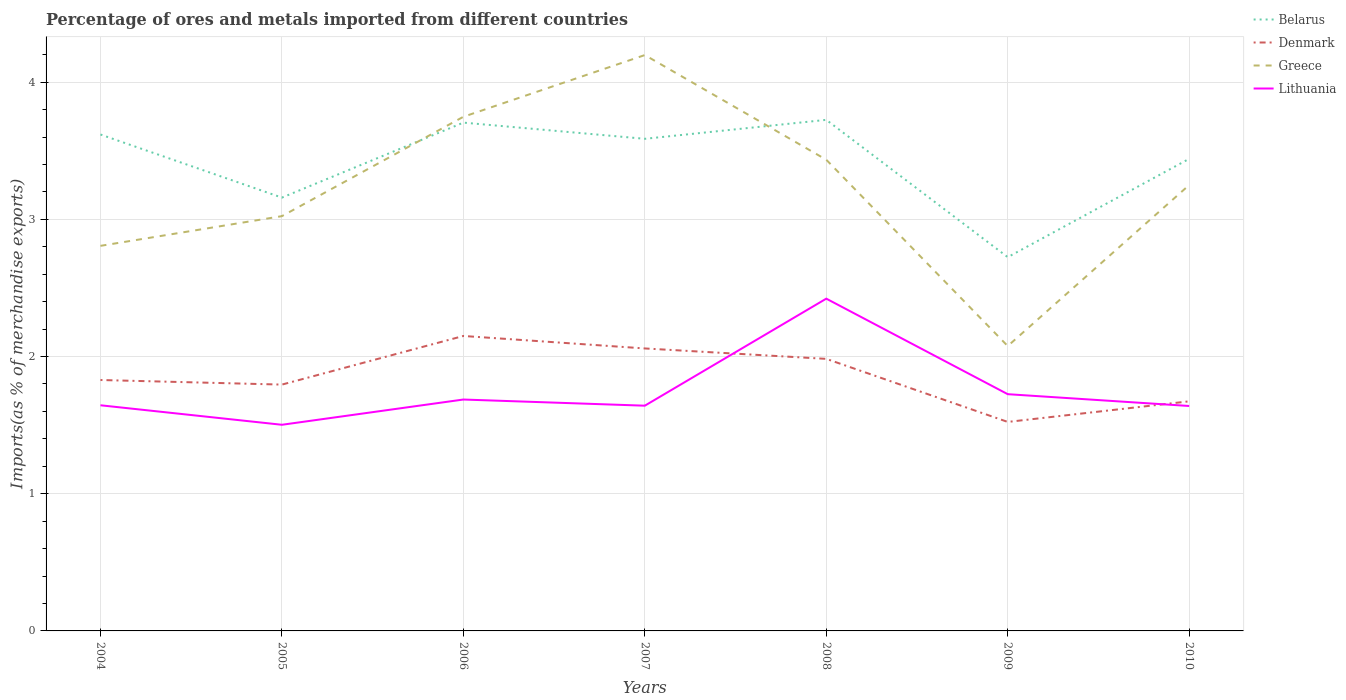How many different coloured lines are there?
Make the answer very short. 4. Does the line corresponding to Belarus intersect with the line corresponding to Greece?
Ensure brevity in your answer.  Yes. Is the number of lines equal to the number of legend labels?
Give a very brief answer. Yes. Across all years, what is the maximum percentage of imports to different countries in Greece?
Offer a very short reply. 2.08. What is the total percentage of imports to different countries in Lithuania in the graph?
Your answer should be compact. 0.01. What is the difference between the highest and the second highest percentage of imports to different countries in Denmark?
Ensure brevity in your answer.  0.63. Is the percentage of imports to different countries in Belarus strictly greater than the percentage of imports to different countries in Denmark over the years?
Ensure brevity in your answer.  No. How many lines are there?
Ensure brevity in your answer.  4. How many years are there in the graph?
Your answer should be very brief. 7. What is the difference between two consecutive major ticks on the Y-axis?
Offer a terse response. 1. Are the values on the major ticks of Y-axis written in scientific E-notation?
Your response must be concise. No. How many legend labels are there?
Your response must be concise. 4. How are the legend labels stacked?
Your answer should be very brief. Vertical. What is the title of the graph?
Offer a very short reply. Percentage of ores and metals imported from different countries. Does "East Asia (developing only)" appear as one of the legend labels in the graph?
Your response must be concise. No. What is the label or title of the X-axis?
Make the answer very short. Years. What is the label or title of the Y-axis?
Your response must be concise. Imports(as % of merchandise exports). What is the Imports(as % of merchandise exports) of Belarus in 2004?
Make the answer very short. 3.62. What is the Imports(as % of merchandise exports) of Denmark in 2004?
Make the answer very short. 1.83. What is the Imports(as % of merchandise exports) of Greece in 2004?
Make the answer very short. 2.81. What is the Imports(as % of merchandise exports) of Lithuania in 2004?
Your answer should be very brief. 1.64. What is the Imports(as % of merchandise exports) of Belarus in 2005?
Keep it short and to the point. 3.16. What is the Imports(as % of merchandise exports) of Denmark in 2005?
Give a very brief answer. 1.8. What is the Imports(as % of merchandise exports) in Greece in 2005?
Offer a very short reply. 3.02. What is the Imports(as % of merchandise exports) of Lithuania in 2005?
Offer a terse response. 1.5. What is the Imports(as % of merchandise exports) in Belarus in 2006?
Your response must be concise. 3.71. What is the Imports(as % of merchandise exports) in Denmark in 2006?
Offer a terse response. 2.15. What is the Imports(as % of merchandise exports) of Greece in 2006?
Provide a succinct answer. 3.75. What is the Imports(as % of merchandise exports) of Lithuania in 2006?
Your response must be concise. 1.69. What is the Imports(as % of merchandise exports) in Belarus in 2007?
Keep it short and to the point. 3.59. What is the Imports(as % of merchandise exports) of Denmark in 2007?
Your answer should be very brief. 2.06. What is the Imports(as % of merchandise exports) in Greece in 2007?
Provide a short and direct response. 4.2. What is the Imports(as % of merchandise exports) of Lithuania in 2007?
Provide a short and direct response. 1.64. What is the Imports(as % of merchandise exports) in Belarus in 2008?
Ensure brevity in your answer.  3.73. What is the Imports(as % of merchandise exports) in Denmark in 2008?
Make the answer very short. 1.98. What is the Imports(as % of merchandise exports) in Greece in 2008?
Ensure brevity in your answer.  3.43. What is the Imports(as % of merchandise exports) of Lithuania in 2008?
Ensure brevity in your answer.  2.42. What is the Imports(as % of merchandise exports) in Belarus in 2009?
Provide a succinct answer. 2.72. What is the Imports(as % of merchandise exports) of Denmark in 2009?
Ensure brevity in your answer.  1.52. What is the Imports(as % of merchandise exports) of Greece in 2009?
Ensure brevity in your answer.  2.08. What is the Imports(as % of merchandise exports) in Lithuania in 2009?
Your answer should be very brief. 1.73. What is the Imports(as % of merchandise exports) of Belarus in 2010?
Offer a very short reply. 3.44. What is the Imports(as % of merchandise exports) of Denmark in 2010?
Your answer should be very brief. 1.67. What is the Imports(as % of merchandise exports) in Greece in 2010?
Your answer should be compact. 3.25. What is the Imports(as % of merchandise exports) of Lithuania in 2010?
Make the answer very short. 1.64. Across all years, what is the maximum Imports(as % of merchandise exports) of Belarus?
Make the answer very short. 3.73. Across all years, what is the maximum Imports(as % of merchandise exports) of Denmark?
Offer a very short reply. 2.15. Across all years, what is the maximum Imports(as % of merchandise exports) of Greece?
Make the answer very short. 4.2. Across all years, what is the maximum Imports(as % of merchandise exports) of Lithuania?
Offer a very short reply. 2.42. Across all years, what is the minimum Imports(as % of merchandise exports) in Belarus?
Keep it short and to the point. 2.72. Across all years, what is the minimum Imports(as % of merchandise exports) of Denmark?
Your response must be concise. 1.52. Across all years, what is the minimum Imports(as % of merchandise exports) of Greece?
Your answer should be compact. 2.08. Across all years, what is the minimum Imports(as % of merchandise exports) of Lithuania?
Offer a very short reply. 1.5. What is the total Imports(as % of merchandise exports) in Belarus in the graph?
Provide a succinct answer. 23.96. What is the total Imports(as % of merchandise exports) of Denmark in the graph?
Provide a short and direct response. 13.01. What is the total Imports(as % of merchandise exports) of Greece in the graph?
Your response must be concise. 22.54. What is the total Imports(as % of merchandise exports) of Lithuania in the graph?
Your answer should be very brief. 12.26. What is the difference between the Imports(as % of merchandise exports) in Belarus in 2004 and that in 2005?
Make the answer very short. 0.46. What is the difference between the Imports(as % of merchandise exports) of Denmark in 2004 and that in 2005?
Provide a short and direct response. 0.03. What is the difference between the Imports(as % of merchandise exports) of Greece in 2004 and that in 2005?
Your response must be concise. -0.22. What is the difference between the Imports(as % of merchandise exports) of Lithuania in 2004 and that in 2005?
Give a very brief answer. 0.14. What is the difference between the Imports(as % of merchandise exports) of Belarus in 2004 and that in 2006?
Provide a succinct answer. -0.09. What is the difference between the Imports(as % of merchandise exports) in Denmark in 2004 and that in 2006?
Offer a very short reply. -0.32. What is the difference between the Imports(as % of merchandise exports) of Greece in 2004 and that in 2006?
Keep it short and to the point. -0.94. What is the difference between the Imports(as % of merchandise exports) in Lithuania in 2004 and that in 2006?
Provide a short and direct response. -0.04. What is the difference between the Imports(as % of merchandise exports) in Belarus in 2004 and that in 2007?
Your response must be concise. 0.03. What is the difference between the Imports(as % of merchandise exports) of Denmark in 2004 and that in 2007?
Your response must be concise. -0.23. What is the difference between the Imports(as % of merchandise exports) in Greece in 2004 and that in 2007?
Offer a terse response. -1.39. What is the difference between the Imports(as % of merchandise exports) in Lithuania in 2004 and that in 2007?
Provide a succinct answer. 0. What is the difference between the Imports(as % of merchandise exports) in Belarus in 2004 and that in 2008?
Offer a terse response. -0.11. What is the difference between the Imports(as % of merchandise exports) in Denmark in 2004 and that in 2008?
Your response must be concise. -0.15. What is the difference between the Imports(as % of merchandise exports) in Greece in 2004 and that in 2008?
Your answer should be very brief. -0.63. What is the difference between the Imports(as % of merchandise exports) of Lithuania in 2004 and that in 2008?
Keep it short and to the point. -0.78. What is the difference between the Imports(as % of merchandise exports) in Belarus in 2004 and that in 2009?
Give a very brief answer. 0.89. What is the difference between the Imports(as % of merchandise exports) of Denmark in 2004 and that in 2009?
Provide a short and direct response. 0.31. What is the difference between the Imports(as % of merchandise exports) in Greece in 2004 and that in 2009?
Ensure brevity in your answer.  0.73. What is the difference between the Imports(as % of merchandise exports) in Lithuania in 2004 and that in 2009?
Your response must be concise. -0.08. What is the difference between the Imports(as % of merchandise exports) in Belarus in 2004 and that in 2010?
Your answer should be compact. 0.18. What is the difference between the Imports(as % of merchandise exports) in Denmark in 2004 and that in 2010?
Provide a succinct answer. 0.16. What is the difference between the Imports(as % of merchandise exports) of Greece in 2004 and that in 2010?
Make the answer very short. -0.44. What is the difference between the Imports(as % of merchandise exports) in Lithuania in 2004 and that in 2010?
Offer a very short reply. 0.01. What is the difference between the Imports(as % of merchandise exports) of Belarus in 2005 and that in 2006?
Give a very brief answer. -0.55. What is the difference between the Imports(as % of merchandise exports) of Denmark in 2005 and that in 2006?
Provide a succinct answer. -0.35. What is the difference between the Imports(as % of merchandise exports) of Greece in 2005 and that in 2006?
Offer a very short reply. -0.72. What is the difference between the Imports(as % of merchandise exports) in Lithuania in 2005 and that in 2006?
Ensure brevity in your answer.  -0.18. What is the difference between the Imports(as % of merchandise exports) of Belarus in 2005 and that in 2007?
Your answer should be compact. -0.43. What is the difference between the Imports(as % of merchandise exports) in Denmark in 2005 and that in 2007?
Provide a short and direct response. -0.26. What is the difference between the Imports(as % of merchandise exports) of Greece in 2005 and that in 2007?
Your answer should be compact. -1.17. What is the difference between the Imports(as % of merchandise exports) of Lithuania in 2005 and that in 2007?
Your answer should be compact. -0.14. What is the difference between the Imports(as % of merchandise exports) in Belarus in 2005 and that in 2008?
Keep it short and to the point. -0.57. What is the difference between the Imports(as % of merchandise exports) of Denmark in 2005 and that in 2008?
Ensure brevity in your answer.  -0.19. What is the difference between the Imports(as % of merchandise exports) of Greece in 2005 and that in 2008?
Make the answer very short. -0.41. What is the difference between the Imports(as % of merchandise exports) of Lithuania in 2005 and that in 2008?
Offer a very short reply. -0.92. What is the difference between the Imports(as % of merchandise exports) of Belarus in 2005 and that in 2009?
Give a very brief answer. 0.43. What is the difference between the Imports(as % of merchandise exports) in Denmark in 2005 and that in 2009?
Provide a short and direct response. 0.27. What is the difference between the Imports(as % of merchandise exports) in Greece in 2005 and that in 2009?
Your response must be concise. 0.95. What is the difference between the Imports(as % of merchandise exports) of Lithuania in 2005 and that in 2009?
Ensure brevity in your answer.  -0.22. What is the difference between the Imports(as % of merchandise exports) of Belarus in 2005 and that in 2010?
Ensure brevity in your answer.  -0.28. What is the difference between the Imports(as % of merchandise exports) of Denmark in 2005 and that in 2010?
Your answer should be very brief. 0.12. What is the difference between the Imports(as % of merchandise exports) of Greece in 2005 and that in 2010?
Offer a very short reply. -0.23. What is the difference between the Imports(as % of merchandise exports) of Lithuania in 2005 and that in 2010?
Offer a very short reply. -0.14. What is the difference between the Imports(as % of merchandise exports) in Belarus in 2006 and that in 2007?
Keep it short and to the point. 0.12. What is the difference between the Imports(as % of merchandise exports) of Denmark in 2006 and that in 2007?
Your answer should be compact. 0.09. What is the difference between the Imports(as % of merchandise exports) in Greece in 2006 and that in 2007?
Provide a short and direct response. -0.45. What is the difference between the Imports(as % of merchandise exports) in Lithuania in 2006 and that in 2007?
Provide a succinct answer. 0.04. What is the difference between the Imports(as % of merchandise exports) of Belarus in 2006 and that in 2008?
Ensure brevity in your answer.  -0.02. What is the difference between the Imports(as % of merchandise exports) of Denmark in 2006 and that in 2008?
Your answer should be compact. 0.17. What is the difference between the Imports(as % of merchandise exports) in Greece in 2006 and that in 2008?
Offer a terse response. 0.31. What is the difference between the Imports(as % of merchandise exports) of Lithuania in 2006 and that in 2008?
Give a very brief answer. -0.74. What is the difference between the Imports(as % of merchandise exports) of Belarus in 2006 and that in 2009?
Offer a very short reply. 0.98. What is the difference between the Imports(as % of merchandise exports) of Denmark in 2006 and that in 2009?
Make the answer very short. 0.63. What is the difference between the Imports(as % of merchandise exports) in Greece in 2006 and that in 2009?
Provide a short and direct response. 1.67. What is the difference between the Imports(as % of merchandise exports) in Lithuania in 2006 and that in 2009?
Provide a short and direct response. -0.04. What is the difference between the Imports(as % of merchandise exports) in Belarus in 2006 and that in 2010?
Give a very brief answer. 0.26. What is the difference between the Imports(as % of merchandise exports) in Denmark in 2006 and that in 2010?
Provide a short and direct response. 0.48. What is the difference between the Imports(as % of merchandise exports) of Greece in 2006 and that in 2010?
Keep it short and to the point. 0.5. What is the difference between the Imports(as % of merchandise exports) in Lithuania in 2006 and that in 2010?
Ensure brevity in your answer.  0.05. What is the difference between the Imports(as % of merchandise exports) in Belarus in 2007 and that in 2008?
Your response must be concise. -0.14. What is the difference between the Imports(as % of merchandise exports) in Denmark in 2007 and that in 2008?
Make the answer very short. 0.08. What is the difference between the Imports(as % of merchandise exports) of Greece in 2007 and that in 2008?
Give a very brief answer. 0.76. What is the difference between the Imports(as % of merchandise exports) of Lithuania in 2007 and that in 2008?
Keep it short and to the point. -0.78. What is the difference between the Imports(as % of merchandise exports) in Belarus in 2007 and that in 2009?
Your answer should be very brief. 0.86. What is the difference between the Imports(as % of merchandise exports) in Denmark in 2007 and that in 2009?
Ensure brevity in your answer.  0.54. What is the difference between the Imports(as % of merchandise exports) of Greece in 2007 and that in 2009?
Your response must be concise. 2.12. What is the difference between the Imports(as % of merchandise exports) of Lithuania in 2007 and that in 2009?
Your answer should be compact. -0.08. What is the difference between the Imports(as % of merchandise exports) in Belarus in 2007 and that in 2010?
Your answer should be compact. 0.15. What is the difference between the Imports(as % of merchandise exports) of Denmark in 2007 and that in 2010?
Ensure brevity in your answer.  0.39. What is the difference between the Imports(as % of merchandise exports) of Greece in 2007 and that in 2010?
Offer a terse response. 0.95. What is the difference between the Imports(as % of merchandise exports) of Lithuania in 2007 and that in 2010?
Ensure brevity in your answer.  0. What is the difference between the Imports(as % of merchandise exports) of Denmark in 2008 and that in 2009?
Offer a terse response. 0.46. What is the difference between the Imports(as % of merchandise exports) in Greece in 2008 and that in 2009?
Your answer should be compact. 1.36. What is the difference between the Imports(as % of merchandise exports) in Lithuania in 2008 and that in 2009?
Provide a succinct answer. 0.7. What is the difference between the Imports(as % of merchandise exports) of Belarus in 2008 and that in 2010?
Your answer should be very brief. 0.28. What is the difference between the Imports(as % of merchandise exports) in Denmark in 2008 and that in 2010?
Make the answer very short. 0.31. What is the difference between the Imports(as % of merchandise exports) of Greece in 2008 and that in 2010?
Make the answer very short. 0.18. What is the difference between the Imports(as % of merchandise exports) in Lithuania in 2008 and that in 2010?
Ensure brevity in your answer.  0.78. What is the difference between the Imports(as % of merchandise exports) in Belarus in 2009 and that in 2010?
Offer a terse response. -0.72. What is the difference between the Imports(as % of merchandise exports) of Denmark in 2009 and that in 2010?
Your answer should be very brief. -0.15. What is the difference between the Imports(as % of merchandise exports) of Greece in 2009 and that in 2010?
Offer a very short reply. -1.17. What is the difference between the Imports(as % of merchandise exports) in Lithuania in 2009 and that in 2010?
Offer a terse response. 0.09. What is the difference between the Imports(as % of merchandise exports) of Belarus in 2004 and the Imports(as % of merchandise exports) of Denmark in 2005?
Keep it short and to the point. 1.82. What is the difference between the Imports(as % of merchandise exports) in Belarus in 2004 and the Imports(as % of merchandise exports) in Greece in 2005?
Provide a succinct answer. 0.59. What is the difference between the Imports(as % of merchandise exports) in Belarus in 2004 and the Imports(as % of merchandise exports) in Lithuania in 2005?
Offer a very short reply. 2.12. What is the difference between the Imports(as % of merchandise exports) of Denmark in 2004 and the Imports(as % of merchandise exports) of Greece in 2005?
Your answer should be very brief. -1.19. What is the difference between the Imports(as % of merchandise exports) in Denmark in 2004 and the Imports(as % of merchandise exports) in Lithuania in 2005?
Offer a very short reply. 0.33. What is the difference between the Imports(as % of merchandise exports) of Greece in 2004 and the Imports(as % of merchandise exports) of Lithuania in 2005?
Keep it short and to the point. 1.3. What is the difference between the Imports(as % of merchandise exports) of Belarus in 2004 and the Imports(as % of merchandise exports) of Denmark in 2006?
Offer a terse response. 1.47. What is the difference between the Imports(as % of merchandise exports) of Belarus in 2004 and the Imports(as % of merchandise exports) of Greece in 2006?
Provide a succinct answer. -0.13. What is the difference between the Imports(as % of merchandise exports) of Belarus in 2004 and the Imports(as % of merchandise exports) of Lithuania in 2006?
Your answer should be very brief. 1.93. What is the difference between the Imports(as % of merchandise exports) of Denmark in 2004 and the Imports(as % of merchandise exports) of Greece in 2006?
Provide a succinct answer. -1.92. What is the difference between the Imports(as % of merchandise exports) of Denmark in 2004 and the Imports(as % of merchandise exports) of Lithuania in 2006?
Offer a terse response. 0.14. What is the difference between the Imports(as % of merchandise exports) in Greece in 2004 and the Imports(as % of merchandise exports) in Lithuania in 2006?
Your answer should be compact. 1.12. What is the difference between the Imports(as % of merchandise exports) of Belarus in 2004 and the Imports(as % of merchandise exports) of Denmark in 2007?
Ensure brevity in your answer.  1.56. What is the difference between the Imports(as % of merchandise exports) in Belarus in 2004 and the Imports(as % of merchandise exports) in Greece in 2007?
Keep it short and to the point. -0.58. What is the difference between the Imports(as % of merchandise exports) in Belarus in 2004 and the Imports(as % of merchandise exports) in Lithuania in 2007?
Make the answer very short. 1.98. What is the difference between the Imports(as % of merchandise exports) of Denmark in 2004 and the Imports(as % of merchandise exports) of Greece in 2007?
Offer a very short reply. -2.37. What is the difference between the Imports(as % of merchandise exports) in Denmark in 2004 and the Imports(as % of merchandise exports) in Lithuania in 2007?
Your response must be concise. 0.19. What is the difference between the Imports(as % of merchandise exports) in Greece in 2004 and the Imports(as % of merchandise exports) in Lithuania in 2007?
Your answer should be compact. 1.17. What is the difference between the Imports(as % of merchandise exports) in Belarus in 2004 and the Imports(as % of merchandise exports) in Denmark in 2008?
Provide a short and direct response. 1.64. What is the difference between the Imports(as % of merchandise exports) in Belarus in 2004 and the Imports(as % of merchandise exports) in Greece in 2008?
Provide a succinct answer. 0.18. What is the difference between the Imports(as % of merchandise exports) in Belarus in 2004 and the Imports(as % of merchandise exports) in Lithuania in 2008?
Your response must be concise. 1.2. What is the difference between the Imports(as % of merchandise exports) in Denmark in 2004 and the Imports(as % of merchandise exports) in Greece in 2008?
Provide a short and direct response. -1.61. What is the difference between the Imports(as % of merchandise exports) of Denmark in 2004 and the Imports(as % of merchandise exports) of Lithuania in 2008?
Your answer should be compact. -0.59. What is the difference between the Imports(as % of merchandise exports) in Greece in 2004 and the Imports(as % of merchandise exports) in Lithuania in 2008?
Your answer should be compact. 0.38. What is the difference between the Imports(as % of merchandise exports) in Belarus in 2004 and the Imports(as % of merchandise exports) in Denmark in 2009?
Make the answer very short. 2.1. What is the difference between the Imports(as % of merchandise exports) of Belarus in 2004 and the Imports(as % of merchandise exports) of Greece in 2009?
Your answer should be very brief. 1.54. What is the difference between the Imports(as % of merchandise exports) of Belarus in 2004 and the Imports(as % of merchandise exports) of Lithuania in 2009?
Offer a very short reply. 1.89. What is the difference between the Imports(as % of merchandise exports) of Denmark in 2004 and the Imports(as % of merchandise exports) of Greece in 2009?
Provide a succinct answer. -0.25. What is the difference between the Imports(as % of merchandise exports) of Denmark in 2004 and the Imports(as % of merchandise exports) of Lithuania in 2009?
Provide a short and direct response. 0.1. What is the difference between the Imports(as % of merchandise exports) in Greece in 2004 and the Imports(as % of merchandise exports) in Lithuania in 2009?
Give a very brief answer. 1.08. What is the difference between the Imports(as % of merchandise exports) in Belarus in 2004 and the Imports(as % of merchandise exports) in Denmark in 2010?
Your response must be concise. 1.94. What is the difference between the Imports(as % of merchandise exports) of Belarus in 2004 and the Imports(as % of merchandise exports) of Greece in 2010?
Make the answer very short. 0.37. What is the difference between the Imports(as % of merchandise exports) in Belarus in 2004 and the Imports(as % of merchandise exports) in Lithuania in 2010?
Give a very brief answer. 1.98. What is the difference between the Imports(as % of merchandise exports) of Denmark in 2004 and the Imports(as % of merchandise exports) of Greece in 2010?
Provide a succinct answer. -1.42. What is the difference between the Imports(as % of merchandise exports) in Denmark in 2004 and the Imports(as % of merchandise exports) in Lithuania in 2010?
Ensure brevity in your answer.  0.19. What is the difference between the Imports(as % of merchandise exports) of Greece in 2004 and the Imports(as % of merchandise exports) of Lithuania in 2010?
Keep it short and to the point. 1.17. What is the difference between the Imports(as % of merchandise exports) in Belarus in 2005 and the Imports(as % of merchandise exports) in Denmark in 2006?
Offer a very short reply. 1.01. What is the difference between the Imports(as % of merchandise exports) of Belarus in 2005 and the Imports(as % of merchandise exports) of Greece in 2006?
Your answer should be compact. -0.59. What is the difference between the Imports(as % of merchandise exports) in Belarus in 2005 and the Imports(as % of merchandise exports) in Lithuania in 2006?
Make the answer very short. 1.47. What is the difference between the Imports(as % of merchandise exports) in Denmark in 2005 and the Imports(as % of merchandise exports) in Greece in 2006?
Keep it short and to the point. -1.95. What is the difference between the Imports(as % of merchandise exports) in Denmark in 2005 and the Imports(as % of merchandise exports) in Lithuania in 2006?
Make the answer very short. 0.11. What is the difference between the Imports(as % of merchandise exports) of Greece in 2005 and the Imports(as % of merchandise exports) of Lithuania in 2006?
Your answer should be compact. 1.34. What is the difference between the Imports(as % of merchandise exports) in Belarus in 2005 and the Imports(as % of merchandise exports) in Denmark in 2007?
Keep it short and to the point. 1.1. What is the difference between the Imports(as % of merchandise exports) of Belarus in 2005 and the Imports(as % of merchandise exports) of Greece in 2007?
Keep it short and to the point. -1.04. What is the difference between the Imports(as % of merchandise exports) in Belarus in 2005 and the Imports(as % of merchandise exports) in Lithuania in 2007?
Keep it short and to the point. 1.52. What is the difference between the Imports(as % of merchandise exports) in Denmark in 2005 and the Imports(as % of merchandise exports) in Greece in 2007?
Your response must be concise. -2.4. What is the difference between the Imports(as % of merchandise exports) in Denmark in 2005 and the Imports(as % of merchandise exports) in Lithuania in 2007?
Make the answer very short. 0.15. What is the difference between the Imports(as % of merchandise exports) of Greece in 2005 and the Imports(as % of merchandise exports) of Lithuania in 2007?
Keep it short and to the point. 1.38. What is the difference between the Imports(as % of merchandise exports) of Belarus in 2005 and the Imports(as % of merchandise exports) of Denmark in 2008?
Ensure brevity in your answer.  1.18. What is the difference between the Imports(as % of merchandise exports) in Belarus in 2005 and the Imports(as % of merchandise exports) in Greece in 2008?
Keep it short and to the point. -0.28. What is the difference between the Imports(as % of merchandise exports) of Belarus in 2005 and the Imports(as % of merchandise exports) of Lithuania in 2008?
Your response must be concise. 0.74. What is the difference between the Imports(as % of merchandise exports) of Denmark in 2005 and the Imports(as % of merchandise exports) of Greece in 2008?
Provide a short and direct response. -1.64. What is the difference between the Imports(as % of merchandise exports) of Denmark in 2005 and the Imports(as % of merchandise exports) of Lithuania in 2008?
Ensure brevity in your answer.  -0.63. What is the difference between the Imports(as % of merchandise exports) in Greece in 2005 and the Imports(as % of merchandise exports) in Lithuania in 2008?
Offer a terse response. 0.6. What is the difference between the Imports(as % of merchandise exports) in Belarus in 2005 and the Imports(as % of merchandise exports) in Denmark in 2009?
Offer a terse response. 1.64. What is the difference between the Imports(as % of merchandise exports) in Belarus in 2005 and the Imports(as % of merchandise exports) in Greece in 2009?
Provide a short and direct response. 1.08. What is the difference between the Imports(as % of merchandise exports) in Belarus in 2005 and the Imports(as % of merchandise exports) in Lithuania in 2009?
Give a very brief answer. 1.43. What is the difference between the Imports(as % of merchandise exports) in Denmark in 2005 and the Imports(as % of merchandise exports) in Greece in 2009?
Give a very brief answer. -0.28. What is the difference between the Imports(as % of merchandise exports) in Denmark in 2005 and the Imports(as % of merchandise exports) in Lithuania in 2009?
Your answer should be very brief. 0.07. What is the difference between the Imports(as % of merchandise exports) of Greece in 2005 and the Imports(as % of merchandise exports) of Lithuania in 2009?
Make the answer very short. 1.3. What is the difference between the Imports(as % of merchandise exports) of Belarus in 2005 and the Imports(as % of merchandise exports) of Denmark in 2010?
Your answer should be very brief. 1.48. What is the difference between the Imports(as % of merchandise exports) of Belarus in 2005 and the Imports(as % of merchandise exports) of Greece in 2010?
Provide a short and direct response. -0.09. What is the difference between the Imports(as % of merchandise exports) of Belarus in 2005 and the Imports(as % of merchandise exports) of Lithuania in 2010?
Offer a very short reply. 1.52. What is the difference between the Imports(as % of merchandise exports) in Denmark in 2005 and the Imports(as % of merchandise exports) in Greece in 2010?
Offer a terse response. -1.45. What is the difference between the Imports(as % of merchandise exports) in Denmark in 2005 and the Imports(as % of merchandise exports) in Lithuania in 2010?
Your answer should be compact. 0.16. What is the difference between the Imports(as % of merchandise exports) in Greece in 2005 and the Imports(as % of merchandise exports) in Lithuania in 2010?
Ensure brevity in your answer.  1.38. What is the difference between the Imports(as % of merchandise exports) in Belarus in 2006 and the Imports(as % of merchandise exports) in Denmark in 2007?
Offer a very short reply. 1.65. What is the difference between the Imports(as % of merchandise exports) of Belarus in 2006 and the Imports(as % of merchandise exports) of Greece in 2007?
Give a very brief answer. -0.49. What is the difference between the Imports(as % of merchandise exports) of Belarus in 2006 and the Imports(as % of merchandise exports) of Lithuania in 2007?
Ensure brevity in your answer.  2.06. What is the difference between the Imports(as % of merchandise exports) of Denmark in 2006 and the Imports(as % of merchandise exports) of Greece in 2007?
Offer a very short reply. -2.05. What is the difference between the Imports(as % of merchandise exports) in Denmark in 2006 and the Imports(as % of merchandise exports) in Lithuania in 2007?
Provide a short and direct response. 0.51. What is the difference between the Imports(as % of merchandise exports) of Greece in 2006 and the Imports(as % of merchandise exports) of Lithuania in 2007?
Your answer should be very brief. 2.11. What is the difference between the Imports(as % of merchandise exports) in Belarus in 2006 and the Imports(as % of merchandise exports) in Denmark in 2008?
Give a very brief answer. 1.72. What is the difference between the Imports(as % of merchandise exports) of Belarus in 2006 and the Imports(as % of merchandise exports) of Greece in 2008?
Make the answer very short. 0.27. What is the difference between the Imports(as % of merchandise exports) of Belarus in 2006 and the Imports(as % of merchandise exports) of Lithuania in 2008?
Your answer should be very brief. 1.28. What is the difference between the Imports(as % of merchandise exports) of Denmark in 2006 and the Imports(as % of merchandise exports) of Greece in 2008?
Ensure brevity in your answer.  -1.28. What is the difference between the Imports(as % of merchandise exports) in Denmark in 2006 and the Imports(as % of merchandise exports) in Lithuania in 2008?
Ensure brevity in your answer.  -0.27. What is the difference between the Imports(as % of merchandise exports) in Greece in 2006 and the Imports(as % of merchandise exports) in Lithuania in 2008?
Provide a short and direct response. 1.33. What is the difference between the Imports(as % of merchandise exports) in Belarus in 2006 and the Imports(as % of merchandise exports) in Denmark in 2009?
Provide a succinct answer. 2.18. What is the difference between the Imports(as % of merchandise exports) of Belarus in 2006 and the Imports(as % of merchandise exports) of Greece in 2009?
Offer a terse response. 1.63. What is the difference between the Imports(as % of merchandise exports) of Belarus in 2006 and the Imports(as % of merchandise exports) of Lithuania in 2009?
Provide a succinct answer. 1.98. What is the difference between the Imports(as % of merchandise exports) in Denmark in 2006 and the Imports(as % of merchandise exports) in Greece in 2009?
Make the answer very short. 0.07. What is the difference between the Imports(as % of merchandise exports) in Denmark in 2006 and the Imports(as % of merchandise exports) in Lithuania in 2009?
Provide a succinct answer. 0.42. What is the difference between the Imports(as % of merchandise exports) in Greece in 2006 and the Imports(as % of merchandise exports) in Lithuania in 2009?
Your answer should be compact. 2.02. What is the difference between the Imports(as % of merchandise exports) of Belarus in 2006 and the Imports(as % of merchandise exports) of Denmark in 2010?
Your answer should be very brief. 2.03. What is the difference between the Imports(as % of merchandise exports) of Belarus in 2006 and the Imports(as % of merchandise exports) of Greece in 2010?
Make the answer very short. 0.45. What is the difference between the Imports(as % of merchandise exports) in Belarus in 2006 and the Imports(as % of merchandise exports) in Lithuania in 2010?
Ensure brevity in your answer.  2.07. What is the difference between the Imports(as % of merchandise exports) in Denmark in 2006 and the Imports(as % of merchandise exports) in Greece in 2010?
Offer a terse response. -1.1. What is the difference between the Imports(as % of merchandise exports) of Denmark in 2006 and the Imports(as % of merchandise exports) of Lithuania in 2010?
Give a very brief answer. 0.51. What is the difference between the Imports(as % of merchandise exports) of Greece in 2006 and the Imports(as % of merchandise exports) of Lithuania in 2010?
Offer a very short reply. 2.11. What is the difference between the Imports(as % of merchandise exports) of Belarus in 2007 and the Imports(as % of merchandise exports) of Denmark in 2008?
Your answer should be very brief. 1.6. What is the difference between the Imports(as % of merchandise exports) of Belarus in 2007 and the Imports(as % of merchandise exports) of Greece in 2008?
Your answer should be very brief. 0.15. What is the difference between the Imports(as % of merchandise exports) of Belarus in 2007 and the Imports(as % of merchandise exports) of Lithuania in 2008?
Provide a succinct answer. 1.17. What is the difference between the Imports(as % of merchandise exports) in Denmark in 2007 and the Imports(as % of merchandise exports) in Greece in 2008?
Your answer should be very brief. -1.38. What is the difference between the Imports(as % of merchandise exports) in Denmark in 2007 and the Imports(as % of merchandise exports) in Lithuania in 2008?
Offer a terse response. -0.36. What is the difference between the Imports(as % of merchandise exports) of Greece in 2007 and the Imports(as % of merchandise exports) of Lithuania in 2008?
Provide a succinct answer. 1.78. What is the difference between the Imports(as % of merchandise exports) of Belarus in 2007 and the Imports(as % of merchandise exports) of Denmark in 2009?
Make the answer very short. 2.06. What is the difference between the Imports(as % of merchandise exports) of Belarus in 2007 and the Imports(as % of merchandise exports) of Greece in 2009?
Your answer should be compact. 1.51. What is the difference between the Imports(as % of merchandise exports) of Belarus in 2007 and the Imports(as % of merchandise exports) of Lithuania in 2009?
Offer a terse response. 1.86. What is the difference between the Imports(as % of merchandise exports) of Denmark in 2007 and the Imports(as % of merchandise exports) of Greece in 2009?
Provide a short and direct response. -0.02. What is the difference between the Imports(as % of merchandise exports) in Denmark in 2007 and the Imports(as % of merchandise exports) in Lithuania in 2009?
Give a very brief answer. 0.33. What is the difference between the Imports(as % of merchandise exports) of Greece in 2007 and the Imports(as % of merchandise exports) of Lithuania in 2009?
Keep it short and to the point. 2.47. What is the difference between the Imports(as % of merchandise exports) of Belarus in 2007 and the Imports(as % of merchandise exports) of Denmark in 2010?
Ensure brevity in your answer.  1.91. What is the difference between the Imports(as % of merchandise exports) in Belarus in 2007 and the Imports(as % of merchandise exports) in Greece in 2010?
Offer a very short reply. 0.34. What is the difference between the Imports(as % of merchandise exports) of Belarus in 2007 and the Imports(as % of merchandise exports) of Lithuania in 2010?
Offer a terse response. 1.95. What is the difference between the Imports(as % of merchandise exports) in Denmark in 2007 and the Imports(as % of merchandise exports) in Greece in 2010?
Your response must be concise. -1.19. What is the difference between the Imports(as % of merchandise exports) of Denmark in 2007 and the Imports(as % of merchandise exports) of Lithuania in 2010?
Provide a succinct answer. 0.42. What is the difference between the Imports(as % of merchandise exports) in Greece in 2007 and the Imports(as % of merchandise exports) in Lithuania in 2010?
Your answer should be compact. 2.56. What is the difference between the Imports(as % of merchandise exports) of Belarus in 2008 and the Imports(as % of merchandise exports) of Denmark in 2009?
Keep it short and to the point. 2.2. What is the difference between the Imports(as % of merchandise exports) of Belarus in 2008 and the Imports(as % of merchandise exports) of Greece in 2009?
Your answer should be compact. 1.65. What is the difference between the Imports(as % of merchandise exports) in Belarus in 2008 and the Imports(as % of merchandise exports) in Lithuania in 2009?
Offer a terse response. 2. What is the difference between the Imports(as % of merchandise exports) in Denmark in 2008 and the Imports(as % of merchandise exports) in Greece in 2009?
Your response must be concise. -0.09. What is the difference between the Imports(as % of merchandise exports) of Denmark in 2008 and the Imports(as % of merchandise exports) of Lithuania in 2009?
Keep it short and to the point. 0.26. What is the difference between the Imports(as % of merchandise exports) in Greece in 2008 and the Imports(as % of merchandise exports) in Lithuania in 2009?
Provide a succinct answer. 1.71. What is the difference between the Imports(as % of merchandise exports) of Belarus in 2008 and the Imports(as % of merchandise exports) of Denmark in 2010?
Your answer should be compact. 2.05. What is the difference between the Imports(as % of merchandise exports) of Belarus in 2008 and the Imports(as % of merchandise exports) of Greece in 2010?
Provide a short and direct response. 0.47. What is the difference between the Imports(as % of merchandise exports) in Belarus in 2008 and the Imports(as % of merchandise exports) in Lithuania in 2010?
Provide a short and direct response. 2.09. What is the difference between the Imports(as % of merchandise exports) in Denmark in 2008 and the Imports(as % of merchandise exports) in Greece in 2010?
Provide a succinct answer. -1.27. What is the difference between the Imports(as % of merchandise exports) in Denmark in 2008 and the Imports(as % of merchandise exports) in Lithuania in 2010?
Ensure brevity in your answer.  0.34. What is the difference between the Imports(as % of merchandise exports) in Greece in 2008 and the Imports(as % of merchandise exports) in Lithuania in 2010?
Give a very brief answer. 1.79. What is the difference between the Imports(as % of merchandise exports) in Belarus in 2009 and the Imports(as % of merchandise exports) in Denmark in 2010?
Your answer should be compact. 1.05. What is the difference between the Imports(as % of merchandise exports) in Belarus in 2009 and the Imports(as % of merchandise exports) in Greece in 2010?
Make the answer very short. -0.53. What is the difference between the Imports(as % of merchandise exports) of Belarus in 2009 and the Imports(as % of merchandise exports) of Lithuania in 2010?
Your answer should be very brief. 1.08. What is the difference between the Imports(as % of merchandise exports) of Denmark in 2009 and the Imports(as % of merchandise exports) of Greece in 2010?
Your response must be concise. -1.73. What is the difference between the Imports(as % of merchandise exports) of Denmark in 2009 and the Imports(as % of merchandise exports) of Lithuania in 2010?
Your response must be concise. -0.12. What is the difference between the Imports(as % of merchandise exports) of Greece in 2009 and the Imports(as % of merchandise exports) of Lithuania in 2010?
Make the answer very short. 0.44. What is the average Imports(as % of merchandise exports) in Belarus per year?
Your response must be concise. 3.42. What is the average Imports(as % of merchandise exports) of Denmark per year?
Provide a short and direct response. 1.86. What is the average Imports(as % of merchandise exports) in Greece per year?
Provide a short and direct response. 3.22. What is the average Imports(as % of merchandise exports) in Lithuania per year?
Make the answer very short. 1.75. In the year 2004, what is the difference between the Imports(as % of merchandise exports) in Belarus and Imports(as % of merchandise exports) in Denmark?
Offer a very short reply. 1.79. In the year 2004, what is the difference between the Imports(as % of merchandise exports) in Belarus and Imports(as % of merchandise exports) in Greece?
Keep it short and to the point. 0.81. In the year 2004, what is the difference between the Imports(as % of merchandise exports) of Belarus and Imports(as % of merchandise exports) of Lithuania?
Offer a very short reply. 1.97. In the year 2004, what is the difference between the Imports(as % of merchandise exports) of Denmark and Imports(as % of merchandise exports) of Greece?
Make the answer very short. -0.98. In the year 2004, what is the difference between the Imports(as % of merchandise exports) of Denmark and Imports(as % of merchandise exports) of Lithuania?
Make the answer very short. 0.18. In the year 2004, what is the difference between the Imports(as % of merchandise exports) in Greece and Imports(as % of merchandise exports) in Lithuania?
Your answer should be compact. 1.16. In the year 2005, what is the difference between the Imports(as % of merchandise exports) of Belarus and Imports(as % of merchandise exports) of Denmark?
Give a very brief answer. 1.36. In the year 2005, what is the difference between the Imports(as % of merchandise exports) in Belarus and Imports(as % of merchandise exports) in Greece?
Ensure brevity in your answer.  0.14. In the year 2005, what is the difference between the Imports(as % of merchandise exports) of Belarus and Imports(as % of merchandise exports) of Lithuania?
Offer a terse response. 1.66. In the year 2005, what is the difference between the Imports(as % of merchandise exports) in Denmark and Imports(as % of merchandise exports) in Greece?
Your answer should be compact. -1.23. In the year 2005, what is the difference between the Imports(as % of merchandise exports) of Denmark and Imports(as % of merchandise exports) of Lithuania?
Offer a very short reply. 0.29. In the year 2005, what is the difference between the Imports(as % of merchandise exports) in Greece and Imports(as % of merchandise exports) in Lithuania?
Make the answer very short. 1.52. In the year 2006, what is the difference between the Imports(as % of merchandise exports) in Belarus and Imports(as % of merchandise exports) in Denmark?
Ensure brevity in your answer.  1.56. In the year 2006, what is the difference between the Imports(as % of merchandise exports) of Belarus and Imports(as % of merchandise exports) of Greece?
Make the answer very short. -0.04. In the year 2006, what is the difference between the Imports(as % of merchandise exports) of Belarus and Imports(as % of merchandise exports) of Lithuania?
Offer a very short reply. 2.02. In the year 2006, what is the difference between the Imports(as % of merchandise exports) in Denmark and Imports(as % of merchandise exports) in Greece?
Offer a terse response. -1.6. In the year 2006, what is the difference between the Imports(as % of merchandise exports) of Denmark and Imports(as % of merchandise exports) of Lithuania?
Make the answer very short. 0.46. In the year 2006, what is the difference between the Imports(as % of merchandise exports) in Greece and Imports(as % of merchandise exports) in Lithuania?
Ensure brevity in your answer.  2.06. In the year 2007, what is the difference between the Imports(as % of merchandise exports) in Belarus and Imports(as % of merchandise exports) in Denmark?
Your response must be concise. 1.53. In the year 2007, what is the difference between the Imports(as % of merchandise exports) in Belarus and Imports(as % of merchandise exports) in Greece?
Keep it short and to the point. -0.61. In the year 2007, what is the difference between the Imports(as % of merchandise exports) in Belarus and Imports(as % of merchandise exports) in Lithuania?
Offer a terse response. 1.95. In the year 2007, what is the difference between the Imports(as % of merchandise exports) of Denmark and Imports(as % of merchandise exports) of Greece?
Your answer should be very brief. -2.14. In the year 2007, what is the difference between the Imports(as % of merchandise exports) in Denmark and Imports(as % of merchandise exports) in Lithuania?
Your answer should be very brief. 0.42. In the year 2007, what is the difference between the Imports(as % of merchandise exports) in Greece and Imports(as % of merchandise exports) in Lithuania?
Provide a short and direct response. 2.56. In the year 2008, what is the difference between the Imports(as % of merchandise exports) in Belarus and Imports(as % of merchandise exports) in Denmark?
Make the answer very short. 1.74. In the year 2008, what is the difference between the Imports(as % of merchandise exports) in Belarus and Imports(as % of merchandise exports) in Greece?
Make the answer very short. 0.29. In the year 2008, what is the difference between the Imports(as % of merchandise exports) of Belarus and Imports(as % of merchandise exports) of Lithuania?
Offer a terse response. 1.3. In the year 2008, what is the difference between the Imports(as % of merchandise exports) of Denmark and Imports(as % of merchandise exports) of Greece?
Ensure brevity in your answer.  -1.45. In the year 2008, what is the difference between the Imports(as % of merchandise exports) in Denmark and Imports(as % of merchandise exports) in Lithuania?
Offer a terse response. -0.44. In the year 2008, what is the difference between the Imports(as % of merchandise exports) in Greece and Imports(as % of merchandise exports) in Lithuania?
Your response must be concise. 1.01. In the year 2009, what is the difference between the Imports(as % of merchandise exports) in Belarus and Imports(as % of merchandise exports) in Denmark?
Ensure brevity in your answer.  1.2. In the year 2009, what is the difference between the Imports(as % of merchandise exports) of Belarus and Imports(as % of merchandise exports) of Greece?
Your answer should be very brief. 0.65. In the year 2009, what is the difference between the Imports(as % of merchandise exports) in Denmark and Imports(as % of merchandise exports) in Greece?
Provide a short and direct response. -0.55. In the year 2009, what is the difference between the Imports(as % of merchandise exports) of Denmark and Imports(as % of merchandise exports) of Lithuania?
Provide a short and direct response. -0.2. In the year 2009, what is the difference between the Imports(as % of merchandise exports) in Greece and Imports(as % of merchandise exports) in Lithuania?
Offer a very short reply. 0.35. In the year 2010, what is the difference between the Imports(as % of merchandise exports) of Belarus and Imports(as % of merchandise exports) of Denmark?
Offer a terse response. 1.77. In the year 2010, what is the difference between the Imports(as % of merchandise exports) of Belarus and Imports(as % of merchandise exports) of Greece?
Make the answer very short. 0.19. In the year 2010, what is the difference between the Imports(as % of merchandise exports) in Belarus and Imports(as % of merchandise exports) in Lithuania?
Your response must be concise. 1.8. In the year 2010, what is the difference between the Imports(as % of merchandise exports) in Denmark and Imports(as % of merchandise exports) in Greece?
Provide a short and direct response. -1.58. In the year 2010, what is the difference between the Imports(as % of merchandise exports) of Denmark and Imports(as % of merchandise exports) of Lithuania?
Your answer should be very brief. 0.03. In the year 2010, what is the difference between the Imports(as % of merchandise exports) of Greece and Imports(as % of merchandise exports) of Lithuania?
Your answer should be compact. 1.61. What is the ratio of the Imports(as % of merchandise exports) of Belarus in 2004 to that in 2005?
Provide a succinct answer. 1.15. What is the ratio of the Imports(as % of merchandise exports) of Denmark in 2004 to that in 2005?
Keep it short and to the point. 1.02. What is the ratio of the Imports(as % of merchandise exports) of Greece in 2004 to that in 2005?
Your answer should be very brief. 0.93. What is the ratio of the Imports(as % of merchandise exports) of Lithuania in 2004 to that in 2005?
Keep it short and to the point. 1.09. What is the ratio of the Imports(as % of merchandise exports) in Belarus in 2004 to that in 2006?
Your answer should be very brief. 0.98. What is the ratio of the Imports(as % of merchandise exports) in Denmark in 2004 to that in 2006?
Your response must be concise. 0.85. What is the ratio of the Imports(as % of merchandise exports) in Greece in 2004 to that in 2006?
Ensure brevity in your answer.  0.75. What is the ratio of the Imports(as % of merchandise exports) in Lithuania in 2004 to that in 2006?
Give a very brief answer. 0.98. What is the ratio of the Imports(as % of merchandise exports) of Belarus in 2004 to that in 2007?
Your answer should be compact. 1.01. What is the ratio of the Imports(as % of merchandise exports) in Denmark in 2004 to that in 2007?
Your response must be concise. 0.89. What is the ratio of the Imports(as % of merchandise exports) of Greece in 2004 to that in 2007?
Your response must be concise. 0.67. What is the ratio of the Imports(as % of merchandise exports) of Belarus in 2004 to that in 2008?
Keep it short and to the point. 0.97. What is the ratio of the Imports(as % of merchandise exports) in Denmark in 2004 to that in 2008?
Provide a succinct answer. 0.92. What is the ratio of the Imports(as % of merchandise exports) of Greece in 2004 to that in 2008?
Give a very brief answer. 0.82. What is the ratio of the Imports(as % of merchandise exports) of Lithuania in 2004 to that in 2008?
Your answer should be compact. 0.68. What is the ratio of the Imports(as % of merchandise exports) of Belarus in 2004 to that in 2009?
Your response must be concise. 1.33. What is the ratio of the Imports(as % of merchandise exports) in Denmark in 2004 to that in 2009?
Keep it short and to the point. 1.2. What is the ratio of the Imports(as % of merchandise exports) of Greece in 2004 to that in 2009?
Make the answer very short. 1.35. What is the ratio of the Imports(as % of merchandise exports) of Lithuania in 2004 to that in 2009?
Give a very brief answer. 0.95. What is the ratio of the Imports(as % of merchandise exports) in Belarus in 2004 to that in 2010?
Your response must be concise. 1.05. What is the ratio of the Imports(as % of merchandise exports) of Denmark in 2004 to that in 2010?
Your response must be concise. 1.09. What is the ratio of the Imports(as % of merchandise exports) in Greece in 2004 to that in 2010?
Provide a short and direct response. 0.86. What is the ratio of the Imports(as % of merchandise exports) of Belarus in 2005 to that in 2006?
Your response must be concise. 0.85. What is the ratio of the Imports(as % of merchandise exports) in Denmark in 2005 to that in 2006?
Offer a terse response. 0.84. What is the ratio of the Imports(as % of merchandise exports) in Greece in 2005 to that in 2006?
Provide a short and direct response. 0.81. What is the ratio of the Imports(as % of merchandise exports) in Lithuania in 2005 to that in 2006?
Your answer should be very brief. 0.89. What is the ratio of the Imports(as % of merchandise exports) of Belarus in 2005 to that in 2007?
Keep it short and to the point. 0.88. What is the ratio of the Imports(as % of merchandise exports) of Denmark in 2005 to that in 2007?
Keep it short and to the point. 0.87. What is the ratio of the Imports(as % of merchandise exports) of Greece in 2005 to that in 2007?
Offer a terse response. 0.72. What is the ratio of the Imports(as % of merchandise exports) in Lithuania in 2005 to that in 2007?
Your answer should be compact. 0.92. What is the ratio of the Imports(as % of merchandise exports) of Belarus in 2005 to that in 2008?
Your answer should be very brief. 0.85. What is the ratio of the Imports(as % of merchandise exports) in Denmark in 2005 to that in 2008?
Your response must be concise. 0.91. What is the ratio of the Imports(as % of merchandise exports) of Greece in 2005 to that in 2008?
Provide a succinct answer. 0.88. What is the ratio of the Imports(as % of merchandise exports) in Lithuania in 2005 to that in 2008?
Your response must be concise. 0.62. What is the ratio of the Imports(as % of merchandise exports) of Belarus in 2005 to that in 2009?
Make the answer very short. 1.16. What is the ratio of the Imports(as % of merchandise exports) in Denmark in 2005 to that in 2009?
Your answer should be compact. 1.18. What is the ratio of the Imports(as % of merchandise exports) in Greece in 2005 to that in 2009?
Keep it short and to the point. 1.46. What is the ratio of the Imports(as % of merchandise exports) in Lithuania in 2005 to that in 2009?
Keep it short and to the point. 0.87. What is the ratio of the Imports(as % of merchandise exports) of Belarus in 2005 to that in 2010?
Offer a very short reply. 0.92. What is the ratio of the Imports(as % of merchandise exports) of Denmark in 2005 to that in 2010?
Your answer should be compact. 1.07. What is the ratio of the Imports(as % of merchandise exports) of Greece in 2005 to that in 2010?
Offer a terse response. 0.93. What is the ratio of the Imports(as % of merchandise exports) of Lithuania in 2005 to that in 2010?
Offer a very short reply. 0.92. What is the ratio of the Imports(as % of merchandise exports) of Belarus in 2006 to that in 2007?
Your answer should be compact. 1.03. What is the ratio of the Imports(as % of merchandise exports) of Denmark in 2006 to that in 2007?
Keep it short and to the point. 1.04. What is the ratio of the Imports(as % of merchandise exports) of Greece in 2006 to that in 2007?
Provide a succinct answer. 0.89. What is the ratio of the Imports(as % of merchandise exports) in Lithuania in 2006 to that in 2007?
Give a very brief answer. 1.03. What is the ratio of the Imports(as % of merchandise exports) in Belarus in 2006 to that in 2008?
Provide a short and direct response. 0.99. What is the ratio of the Imports(as % of merchandise exports) in Denmark in 2006 to that in 2008?
Keep it short and to the point. 1.08. What is the ratio of the Imports(as % of merchandise exports) of Greece in 2006 to that in 2008?
Offer a terse response. 1.09. What is the ratio of the Imports(as % of merchandise exports) in Lithuania in 2006 to that in 2008?
Make the answer very short. 0.7. What is the ratio of the Imports(as % of merchandise exports) of Belarus in 2006 to that in 2009?
Keep it short and to the point. 1.36. What is the ratio of the Imports(as % of merchandise exports) in Denmark in 2006 to that in 2009?
Offer a very short reply. 1.41. What is the ratio of the Imports(as % of merchandise exports) in Greece in 2006 to that in 2009?
Keep it short and to the point. 1.8. What is the ratio of the Imports(as % of merchandise exports) in Lithuania in 2006 to that in 2009?
Your answer should be very brief. 0.98. What is the ratio of the Imports(as % of merchandise exports) in Belarus in 2006 to that in 2010?
Offer a very short reply. 1.08. What is the ratio of the Imports(as % of merchandise exports) of Denmark in 2006 to that in 2010?
Your answer should be very brief. 1.28. What is the ratio of the Imports(as % of merchandise exports) of Greece in 2006 to that in 2010?
Your answer should be very brief. 1.15. What is the ratio of the Imports(as % of merchandise exports) of Lithuania in 2006 to that in 2010?
Provide a short and direct response. 1.03. What is the ratio of the Imports(as % of merchandise exports) in Belarus in 2007 to that in 2008?
Make the answer very short. 0.96. What is the ratio of the Imports(as % of merchandise exports) of Denmark in 2007 to that in 2008?
Offer a very short reply. 1.04. What is the ratio of the Imports(as % of merchandise exports) in Greece in 2007 to that in 2008?
Offer a very short reply. 1.22. What is the ratio of the Imports(as % of merchandise exports) in Lithuania in 2007 to that in 2008?
Ensure brevity in your answer.  0.68. What is the ratio of the Imports(as % of merchandise exports) of Belarus in 2007 to that in 2009?
Offer a terse response. 1.32. What is the ratio of the Imports(as % of merchandise exports) of Denmark in 2007 to that in 2009?
Give a very brief answer. 1.35. What is the ratio of the Imports(as % of merchandise exports) in Greece in 2007 to that in 2009?
Ensure brevity in your answer.  2.02. What is the ratio of the Imports(as % of merchandise exports) in Lithuania in 2007 to that in 2009?
Make the answer very short. 0.95. What is the ratio of the Imports(as % of merchandise exports) of Belarus in 2007 to that in 2010?
Give a very brief answer. 1.04. What is the ratio of the Imports(as % of merchandise exports) in Denmark in 2007 to that in 2010?
Offer a terse response. 1.23. What is the ratio of the Imports(as % of merchandise exports) of Greece in 2007 to that in 2010?
Your response must be concise. 1.29. What is the ratio of the Imports(as % of merchandise exports) in Lithuania in 2007 to that in 2010?
Your answer should be very brief. 1. What is the ratio of the Imports(as % of merchandise exports) of Belarus in 2008 to that in 2009?
Offer a very short reply. 1.37. What is the ratio of the Imports(as % of merchandise exports) of Denmark in 2008 to that in 2009?
Offer a very short reply. 1.3. What is the ratio of the Imports(as % of merchandise exports) in Greece in 2008 to that in 2009?
Offer a very short reply. 1.65. What is the ratio of the Imports(as % of merchandise exports) of Lithuania in 2008 to that in 2009?
Give a very brief answer. 1.4. What is the ratio of the Imports(as % of merchandise exports) of Belarus in 2008 to that in 2010?
Your answer should be very brief. 1.08. What is the ratio of the Imports(as % of merchandise exports) in Denmark in 2008 to that in 2010?
Provide a succinct answer. 1.18. What is the ratio of the Imports(as % of merchandise exports) in Greece in 2008 to that in 2010?
Your answer should be very brief. 1.06. What is the ratio of the Imports(as % of merchandise exports) of Lithuania in 2008 to that in 2010?
Ensure brevity in your answer.  1.48. What is the ratio of the Imports(as % of merchandise exports) in Belarus in 2009 to that in 2010?
Ensure brevity in your answer.  0.79. What is the ratio of the Imports(as % of merchandise exports) of Denmark in 2009 to that in 2010?
Ensure brevity in your answer.  0.91. What is the ratio of the Imports(as % of merchandise exports) of Greece in 2009 to that in 2010?
Your response must be concise. 0.64. What is the ratio of the Imports(as % of merchandise exports) of Lithuania in 2009 to that in 2010?
Your response must be concise. 1.05. What is the difference between the highest and the second highest Imports(as % of merchandise exports) of Belarus?
Offer a very short reply. 0.02. What is the difference between the highest and the second highest Imports(as % of merchandise exports) in Denmark?
Your response must be concise. 0.09. What is the difference between the highest and the second highest Imports(as % of merchandise exports) in Greece?
Your response must be concise. 0.45. What is the difference between the highest and the second highest Imports(as % of merchandise exports) of Lithuania?
Your response must be concise. 0.7. What is the difference between the highest and the lowest Imports(as % of merchandise exports) in Belarus?
Your answer should be very brief. 1. What is the difference between the highest and the lowest Imports(as % of merchandise exports) of Denmark?
Offer a very short reply. 0.63. What is the difference between the highest and the lowest Imports(as % of merchandise exports) of Greece?
Give a very brief answer. 2.12. What is the difference between the highest and the lowest Imports(as % of merchandise exports) in Lithuania?
Ensure brevity in your answer.  0.92. 